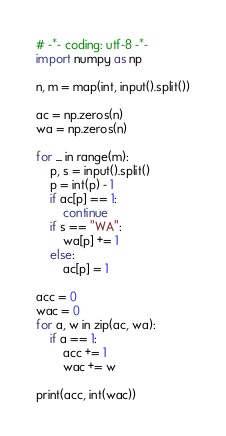<code> <loc_0><loc_0><loc_500><loc_500><_Python_># -*- coding: utf-8 -*-
import numpy as np

n, m = map(int, input().split())

ac = np.zeros(n)
wa = np.zeros(n)

for _ in range(m):
    p, s = input().split()
    p = int(p) - 1
    if ac[p] == 1:
        continue
    if s == "WA":
        wa[p] += 1
    else:
        ac[p] = 1

acc = 0
wac = 0
for a, w in zip(ac, wa):
    if a == 1:
        acc += 1
        wac += w

print(acc, int(wac))
</code> 